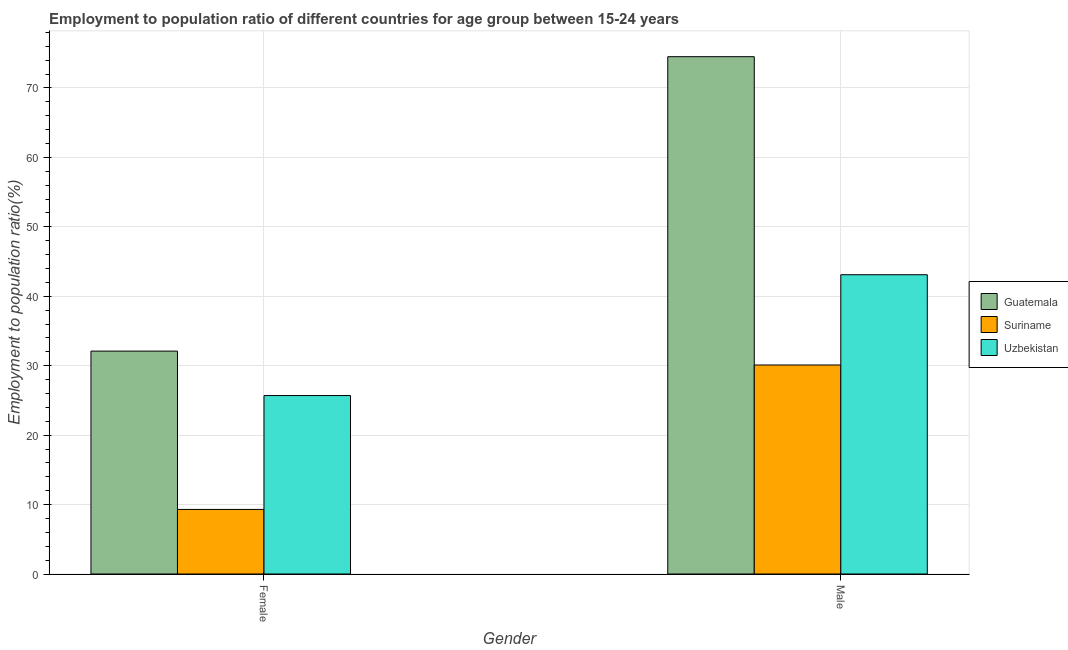How many groups of bars are there?
Provide a short and direct response. 2. How many bars are there on the 1st tick from the right?
Offer a terse response. 3. What is the label of the 2nd group of bars from the left?
Keep it short and to the point. Male. What is the employment to population ratio(female) in Uzbekistan?
Make the answer very short. 25.7. Across all countries, what is the maximum employment to population ratio(female)?
Provide a short and direct response. 32.1. Across all countries, what is the minimum employment to population ratio(female)?
Provide a succinct answer. 9.3. In which country was the employment to population ratio(male) maximum?
Offer a very short reply. Guatemala. In which country was the employment to population ratio(female) minimum?
Your response must be concise. Suriname. What is the total employment to population ratio(female) in the graph?
Your response must be concise. 67.1. What is the difference between the employment to population ratio(male) in Suriname and that in Guatemala?
Offer a very short reply. -44.4. What is the difference between the employment to population ratio(female) in Guatemala and the employment to population ratio(male) in Uzbekistan?
Make the answer very short. -11. What is the average employment to population ratio(male) per country?
Keep it short and to the point. 49.23. What is the difference between the employment to population ratio(female) and employment to population ratio(male) in Guatemala?
Your response must be concise. -42.4. In how many countries, is the employment to population ratio(female) greater than 50 %?
Make the answer very short. 0. What is the ratio of the employment to population ratio(male) in Suriname to that in Guatemala?
Provide a short and direct response. 0.4. In how many countries, is the employment to population ratio(female) greater than the average employment to population ratio(female) taken over all countries?
Ensure brevity in your answer.  2. What does the 3rd bar from the left in Female represents?
Your answer should be compact. Uzbekistan. What does the 2nd bar from the right in Female represents?
Provide a short and direct response. Suriname. Are all the bars in the graph horizontal?
Provide a short and direct response. No. How many countries are there in the graph?
Offer a terse response. 3. Does the graph contain any zero values?
Provide a succinct answer. No. Does the graph contain grids?
Make the answer very short. Yes. Where does the legend appear in the graph?
Offer a very short reply. Center right. How many legend labels are there?
Offer a terse response. 3. What is the title of the graph?
Your answer should be compact. Employment to population ratio of different countries for age group between 15-24 years. Does "Malaysia" appear as one of the legend labels in the graph?
Offer a very short reply. No. What is the Employment to population ratio(%) in Guatemala in Female?
Give a very brief answer. 32.1. What is the Employment to population ratio(%) of Suriname in Female?
Make the answer very short. 9.3. What is the Employment to population ratio(%) in Uzbekistan in Female?
Give a very brief answer. 25.7. What is the Employment to population ratio(%) of Guatemala in Male?
Make the answer very short. 74.5. What is the Employment to population ratio(%) of Suriname in Male?
Provide a succinct answer. 30.1. What is the Employment to population ratio(%) in Uzbekistan in Male?
Your answer should be very brief. 43.1. Across all Gender, what is the maximum Employment to population ratio(%) of Guatemala?
Provide a succinct answer. 74.5. Across all Gender, what is the maximum Employment to population ratio(%) in Suriname?
Offer a very short reply. 30.1. Across all Gender, what is the maximum Employment to population ratio(%) in Uzbekistan?
Keep it short and to the point. 43.1. Across all Gender, what is the minimum Employment to population ratio(%) in Guatemala?
Your answer should be compact. 32.1. Across all Gender, what is the minimum Employment to population ratio(%) in Suriname?
Ensure brevity in your answer.  9.3. Across all Gender, what is the minimum Employment to population ratio(%) of Uzbekistan?
Provide a short and direct response. 25.7. What is the total Employment to population ratio(%) in Guatemala in the graph?
Give a very brief answer. 106.6. What is the total Employment to population ratio(%) of Suriname in the graph?
Keep it short and to the point. 39.4. What is the total Employment to population ratio(%) in Uzbekistan in the graph?
Ensure brevity in your answer.  68.8. What is the difference between the Employment to population ratio(%) of Guatemala in Female and that in Male?
Offer a terse response. -42.4. What is the difference between the Employment to population ratio(%) in Suriname in Female and that in Male?
Make the answer very short. -20.8. What is the difference between the Employment to population ratio(%) of Uzbekistan in Female and that in Male?
Give a very brief answer. -17.4. What is the difference between the Employment to population ratio(%) in Guatemala in Female and the Employment to population ratio(%) in Suriname in Male?
Keep it short and to the point. 2. What is the difference between the Employment to population ratio(%) of Suriname in Female and the Employment to population ratio(%) of Uzbekistan in Male?
Offer a terse response. -33.8. What is the average Employment to population ratio(%) of Guatemala per Gender?
Offer a very short reply. 53.3. What is the average Employment to population ratio(%) of Suriname per Gender?
Provide a succinct answer. 19.7. What is the average Employment to population ratio(%) of Uzbekistan per Gender?
Make the answer very short. 34.4. What is the difference between the Employment to population ratio(%) in Guatemala and Employment to population ratio(%) in Suriname in Female?
Your response must be concise. 22.8. What is the difference between the Employment to population ratio(%) of Suriname and Employment to population ratio(%) of Uzbekistan in Female?
Provide a succinct answer. -16.4. What is the difference between the Employment to population ratio(%) in Guatemala and Employment to population ratio(%) in Suriname in Male?
Provide a succinct answer. 44.4. What is the difference between the Employment to population ratio(%) in Guatemala and Employment to population ratio(%) in Uzbekistan in Male?
Offer a terse response. 31.4. What is the difference between the Employment to population ratio(%) of Suriname and Employment to population ratio(%) of Uzbekistan in Male?
Provide a succinct answer. -13. What is the ratio of the Employment to population ratio(%) in Guatemala in Female to that in Male?
Your answer should be compact. 0.43. What is the ratio of the Employment to population ratio(%) in Suriname in Female to that in Male?
Give a very brief answer. 0.31. What is the ratio of the Employment to population ratio(%) in Uzbekistan in Female to that in Male?
Keep it short and to the point. 0.6. What is the difference between the highest and the second highest Employment to population ratio(%) of Guatemala?
Keep it short and to the point. 42.4. What is the difference between the highest and the second highest Employment to population ratio(%) of Suriname?
Your answer should be compact. 20.8. What is the difference between the highest and the lowest Employment to population ratio(%) in Guatemala?
Make the answer very short. 42.4. What is the difference between the highest and the lowest Employment to population ratio(%) of Suriname?
Provide a succinct answer. 20.8. What is the difference between the highest and the lowest Employment to population ratio(%) in Uzbekistan?
Offer a very short reply. 17.4. 